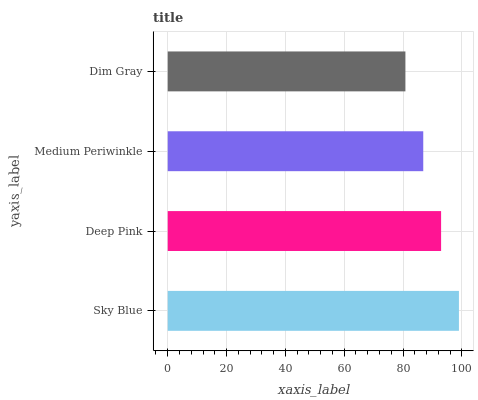Is Dim Gray the minimum?
Answer yes or no. Yes. Is Sky Blue the maximum?
Answer yes or no. Yes. Is Deep Pink the minimum?
Answer yes or no. No. Is Deep Pink the maximum?
Answer yes or no. No. Is Sky Blue greater than Deep Pink?
Answer yes or no. Yes. Is Deep Pink less than Sky Blue?
Answer yes or no. Yes. Is Deep Pink greater than Sky Blue?
Answer yes or no. No. Is Sky Blue less than Deep Pink?
Answer yes or no. No. Is Deep Pink the high median?
Answer yes or no. Yes. Is Medium Periwinkle the low median?
Answer yes or no. Yes. Is Medium Periwinkle the high median?
Answer yes or no. No. Is Sky Blue the low median?
Answer yes or no. No. 